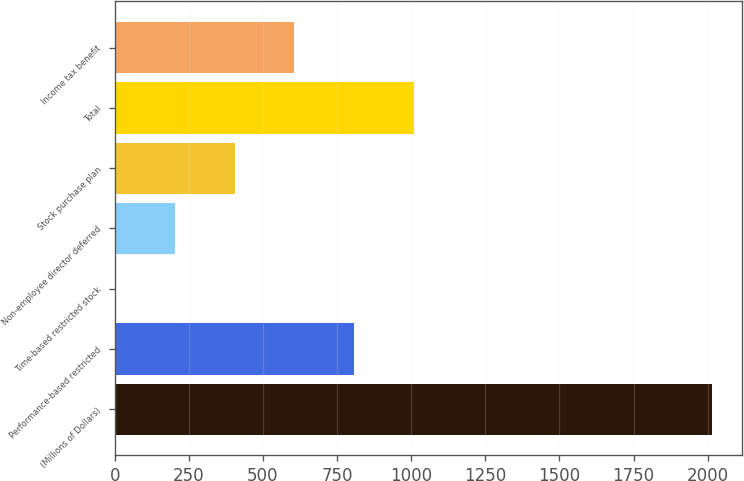Convert chart to OTSL. <chart><loc_0><loc_0><loc_500><loc_500><bar_chart><fcel>(Millions of Dollars)<fcel>Performance-based restricted<fcel>Time-based restricted stock<fcel>Non-employee director deferred<fcel>Stock purchase plan<fcel>Total<fcel>Income tax benefit<nl><fcel>2014<fcel>806.8<fcel>2<fcel>203.2<fcel>404.4<fcel>1008<fcel>605.6<nl></chart> 